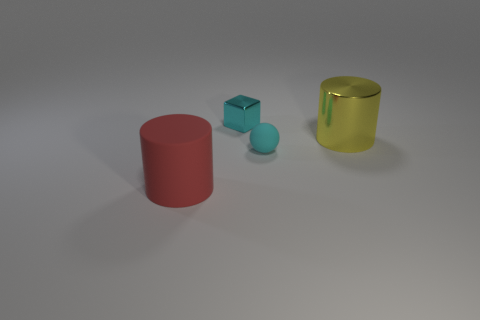What number of yellow objects are blocks or shiny things?
Give a very brief answer. 1. How big is the metallic thing that is in front of the object behind the large cylinder right of the cyan shiny thing?
Provide a short and direct response. Large. How many large things are either rubber cylinders or yellow metal cylinders?
Provide a succinct answer. 2. Does the tiny cyan thing that is behind the large yellow object have the same material as the big thing that is on the left side of the large yellow thing?
Provide a succinct answer. No. What is the material of the big object that is left of the small cyan ball?
Provide a succinct answer. Rubber. How many rubber things are either tiny cylinders or yellow cylinders?
Keep it short and to the point. 0. What color is the shiny thing that is on the left side of the cyan thing that is on the right side of the shiny cube?
Give a very brief answer. Cyan. Does the tiny cyan block have the same material as the cylinder on the left side of the tiny block?
Provide a succinct answer. No. What color is the big object that is in front of the cyan sphere that is on the left side of the cylinder that is right of the rubber cylinder?
Your answer should be compact. Red. Are there any other things that have the same shape as the tiny cyan shiny thing?
Ensure brevity in your answer.  No. 